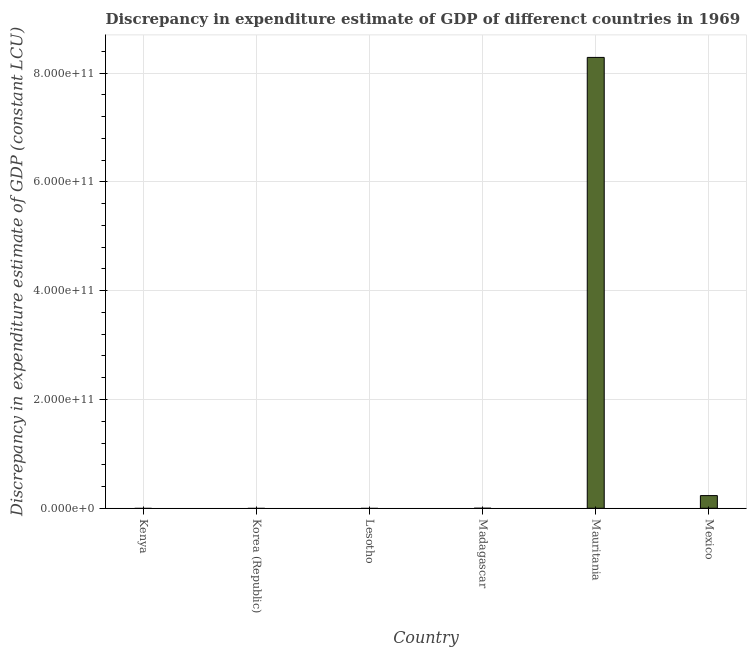Does the graph contain grids?
Your answer should be very brief. Yes. What is the title of the graph?
Your response must be concise. Discrepancy in expenditure estimate of GDP of differenct countries in 1969. What is the label or title of the X-axis?
Keep it short and to the point. Country. What is the label or title of the Y-axis?
Keep it short and to the point. Discrepancy in expenditure estimate of GDP (constant LCU). Across all countries, what is the maximum discrepancy in expenditure estimate of gdp?
Keep it short and to the point. 8.29e+11. Across all countries, what is the minimum discrepancy in expenditure estimate of gdp?
Provide a short and direct response. 0. In which country was the discrepancy in expenditure estimate of gdp maximum?
Make the answer very short. Mauritania. What is the sum of the discrepancy in expenditure estimate of gdp?
Provide a short and direct response. 8.52e+11. What is the average discrepancy in expenditure estimate of gdp per country?
Your response must be concise. 1.42e+11. What is the median discrepancy in expenditure estimate of gdp?
Your response must be concise. 0. In how many countries, is the discrepancy in expenditure estimate of gdp greater than 640000000000 LCU?
Offer a terse response. 1. What is the difference between the highest and the lowest discrepancy in expenditure estimate of gdp?
Make the answer very short. 8.29e+11. Are all the bars in the graph horizontal?
Keep it short and to the point. No. How many countries are there in the graph?
Your response must be concise. 6. What is the difference between two consecutive major ticks on the Y-axis?
Offer a very short reply. 2.00e+11. What is the Discrepancy in expenditure estimate of GDP (constant LCU) in Korea (Republic)?
Offer a very short reply. 0. What is the Discrepancy in expenditure estimate of GDP (constant LCU) in Lesotho?
Your answer should be compact. 0. What is the Discrepancy in expenditure estimate of GDP (constant LCU) in Mauritania?
Make the answer very short. 8.29e+11. What is the Discrepancy in expenditure estimate of GDP (constant LCU) of Mexico?
Make the answer very short. 2.33e+1. What is the difference between the Discrepancy in expenditure estimate of GDP (constant LCU) in Mauritania and Mexico?
Make the answer very short. 8.06e+11. What is the ratio of the Discrepancy in expenditure estimate of GDP (constant LCU) in Mauritania to that in Mexico?
Provide a short and direct response. 35.6. 